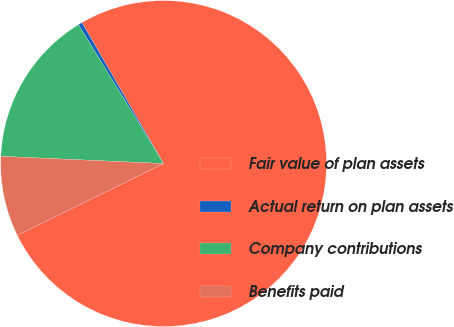<chart> <loc_0><loc_0><loc_500><loc_500><pie_chart><fcel>Fair value of plan assets<fcel>Actual return on plan assets<fcel>Company contributions<fcel>Benefits paid<nl><fcel>76.1%<fcel>0.4%<fcel>15.54%<fcel>7.97%<nl></chart> 